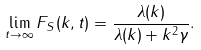Convert formula to latex. <formula><loc_0><loc_0><loc_500><loc_500>\lim _ { t \to \infty } F _ { S } ( k , t ) = \frac { \lambda ( k ) } { \lambda ( k ) + k ^ { 2 } \gamma } .</formula> 